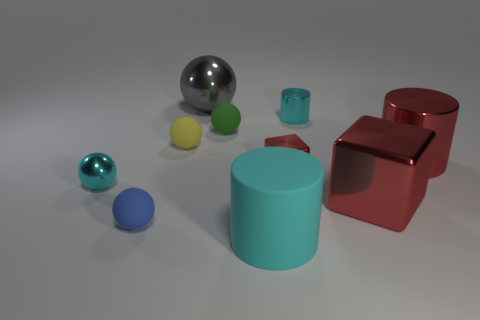Subtract all green spheres. How many spheres are left? 4 Subtract all small cyan metallic balls. How many balls are left? 4 Subtract all blue balls. Subtract all yellow cubes. How many balls are left? 4 Subtract all cubes. How many objects are left? 8 Subtract all big metallic balls. Subtract all red objects. How many objects are left? 6 Add 1 tiny green rubber balls. How many tiny green rubber balls are left? 2 Add 7 tiny metal cubes. How many tiny metal cubes exist? 8 Subtract 1 cyan balls. How many objects are left? 9 